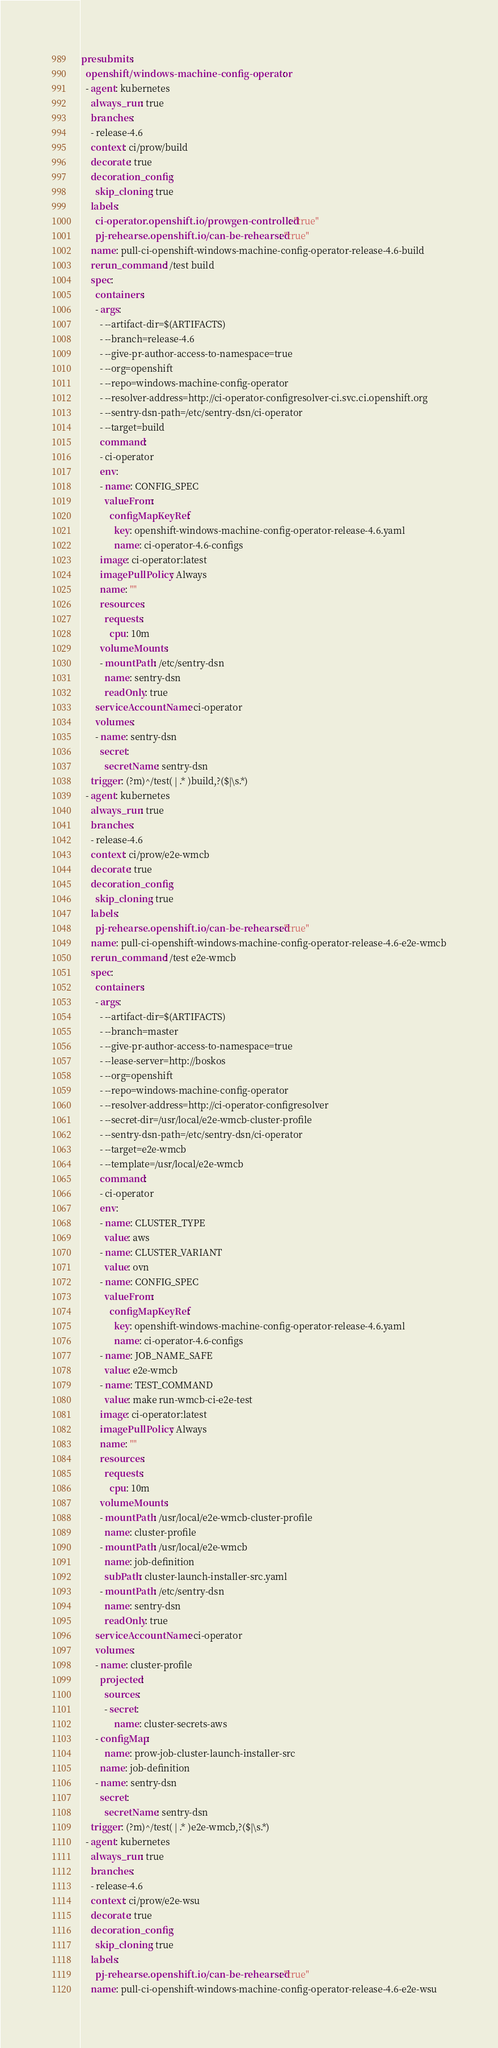<code> <loc_0><loc_0><loc_500><loc_500><_YAML_>presubmits:
  openshift/windows-machine-config-operator:
  - agent: kubernetes
    always_run: true
    branches:
    - release-4.6
    context: ci/prow/build
    decorate: true
    decoration_config:
      skip_cloning: true
    labels:
      ci-operator.openshift.io/prowgen-controlled: "true"
      pj-rehearse.openshift.io/can-be-rehearsed: "true"
    name: pull-ci-openshift-windows-machine-config-operator-release-4.6-build
    rerun_command: /test build
    spec:
      containers:
      - args:
        - --artifact-dir=$(ARTIFACTS)
        - --branch=release-4.6
        - --give-pr-author-access-to-namespace=true
        - --org=openshift
        - --repo=windows-machine-config-operator
        - --resolver-address=http://ci-operator-configresolver-ci.svc.ci.openshift.org
        - --sentry-dsn-path=/etc/sentry-dsn/ci-operator
        - --target=build
        command:
        - ci-operator
        env:
        - name: CONFIG_SPEC
          valueFrom:
            configMapKeyRef:
              key: openshift-windows-machine-config-operator-release-4.6.yaml
              name: ci-operator-4.6-configs
        image: ci-operator:latest
        imagePullPolicy: Always
        name: ""
        resources:
          requests:
            cpu: 10m
        volumeMounts:
        - mountPath: /etc/sentry-dsn
          name: sentry-dsn
          readOnly: true
      serviceAccountName: ci-operator
      volumes:
      - name: sentry-dsn
        secret:
          secretName: sentry-dsn
    trigger: (?m)^/test( | .* )build,?($|\s.*)
  - agent: kubernetes
    always_run: true
    branches:
    - release-4.6
    context: ci/prow/e2e-wmcb
    decorate: true
    decoration_config:
      skip_cloning: true
    labels:
      pj-rehearse.openshift.io/can-be-rehearsed: "true"
    name: pull-ci-openshift-windows-machine-config-operator-release-4.6-e2e-wmcb
    rerun_command: /test e2e-wmcb
    spec:
      containers:
      - args:
        - --artifact-dir=$(ARTIFACTS)
        - --branch=master
        - --give-pr-author-access-to-namespace=true
        - --lease-server=http://boskos
        - --org=openshift
        - --repo=windows-machine-config-operator
        - --resolver-address=http://ci-operator-configresolver
        - --secret-dir=/usr/local/e2e-wmcb-cluster-profile
        - --sentry-dsn-path=/etc/sentry-dsn/ci-operator
        - --target=e2e-wmcb
        - --template=/usr/local/e2e-wmcb
        command:
        - ci-operator
        env:
        - name: CLUSTER_TYPE
          value: aws
        - name: CLUSTER_VARIANT
          value: ovn
        - name: CONFIG_SPEC
          valueFrom:
            configMapKeyRef:
              key: openshift-windows-machine-config-operator-release-4.6.yaml
              name: ci-operator-4.6-configs
        - name: JOB_NAME_SAFE
          value: e2e-wmcb
        - name: TEST_COMMAND
          value: make run-wmcb-ci-e2e-test
        image: ci-operator:latest
        imagePullPolicy: Always
        name: ""
        resources:
          requests:
            cpu: 10m
        volumeMounts:
        - mountPath: /usr/local/e2e-wmcb-cluster-profile
          name: cluster-profile
        - mountPath: /usr/local/e2e-wmcb
          name: job-definition
          subPath: cluster-launch-installer-src.yaml
        - mountPath: /etc/sentry-dsn
          name: sentry-dsn
          readOnly: true
      serviceAccountName: ci-operator
      volumes:
      - name: cluster-profile
        projected:
          sources:
          - secret:
              name: cluster-secrets-aws
      - configMap:
          name: prow-job-cluster-launch-installer-src
        name: job-definition
      - name: sentry-dsn
        secret:
          secretName: sentry-dsn
    trigger: (?m)^/test( | .* )e2e-wmcb,?($|\s.*)
  - agent: kubernetes
    always_run: true
    branches:
    - release-4.6
    context: ci/prow/e2e-wsu
    decorate: true
    decoration_config:
      skip_cloning: true
    labels:
      pj-rehearse.openshift.io/can-be-rehearsed: "true"
    name: pull-ci-openshift-windows-machine-config-operator-release-4.6-e2e-wsu</code> 